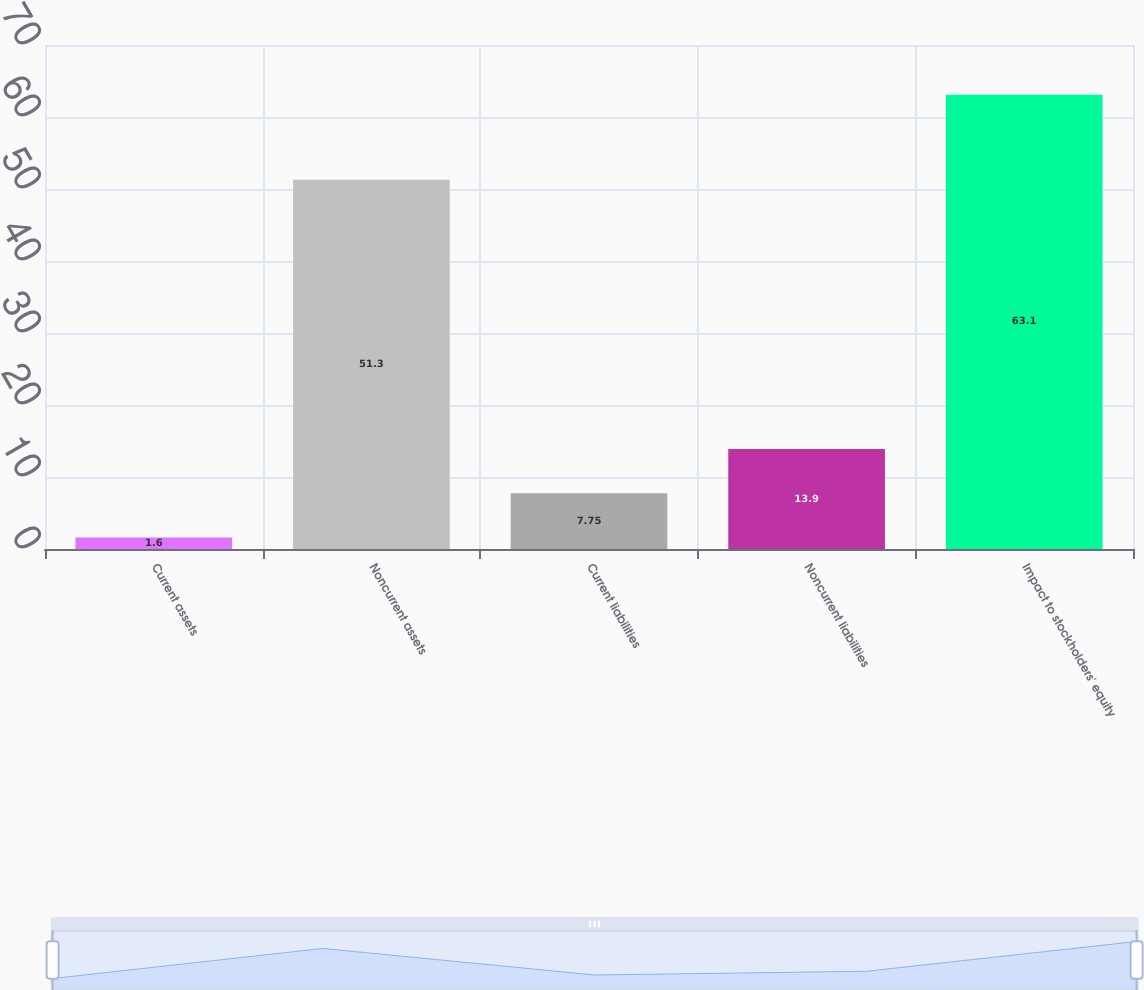Convert chart. <chart><loc_0><loc_0><loc_500><loc_500><bar_chart><fcel>Current assets<fcel>Noncurrent assets<fcel>Current liabilities<fcel>Noncurrent liabilities<fcel>Impact to stockholders' equity<nl><fcel>1.6<fcel>51.3<fcel>7.75<fcel>13.9<fcel>63.1<nl></chart> 